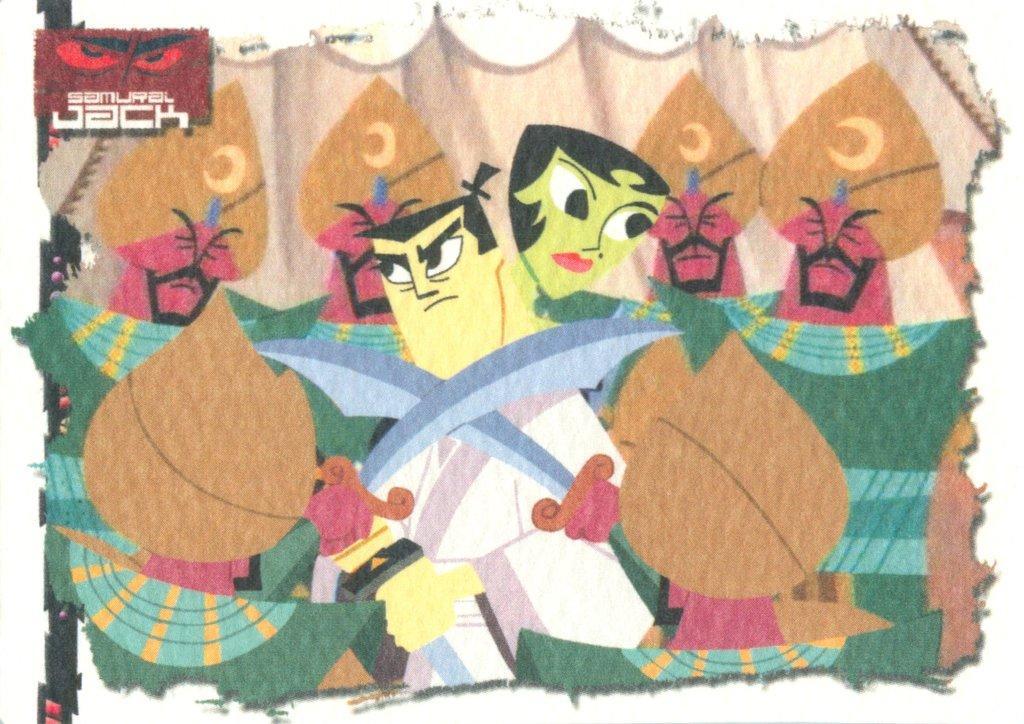Please provide a concise description of this image. This image contains a painting of some persons. A person is holding swords in his hand. Behind him there is a woman. Behind there are four persons wearing caps. In background there is a curtain. 